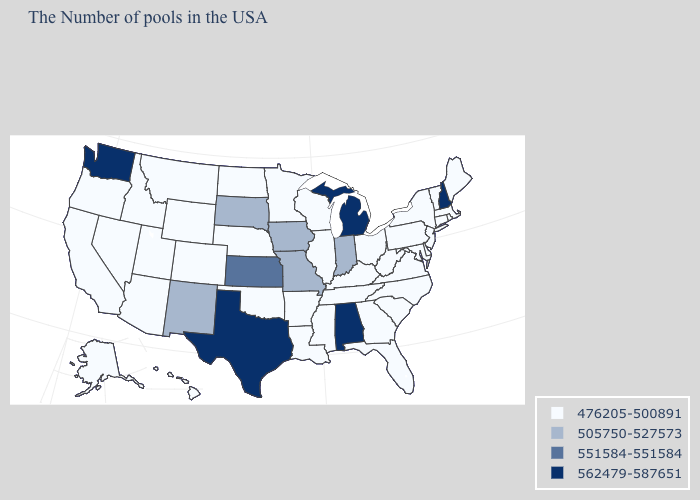Which states hav the highest value in the Northeast?
Concise answer only. New Hampshire. Name the states that have a value in the range 551584-551584?
Quick response, please. Kansas. Is the legend a continuous bar?
Be succinct. No. Does the map have missing data?
Quick response, please. No. Which states hav the highest value in the South?
Concise answer only. Alabama, Texas. Name the states that have a value in the range 476205-500891?
Be succinct. Maine, Massachusetts, Rhode Island, Vermont, Connecticut, New York, New Jersey, Delaware, Maryland, Pennsylvania, Virginia, North Carolina, South Carolina, West Virginia, Ohio, Florida, Georgia, Kentucky, Tennessee, Wisconsin, Illinois, Mississippi, Louisiana, Arkansas, Minnesota, Nebraska, Oklahoma, North Dakota, Wyoming, Colorado, Utah, Montana, Arizona, Idaho, Nevada, California, Oregon, Alaska, Hawaii. Among the states that border North Dakota , which have the highest value?
Write a very short answer. South Dakota. Among the states that border Michigan , which have the lowest value?
Be succinct. Ohio, Wisconsin. How many symbols are there in the legend?
Keep it brief. 4. What is the highest value in the South ?
Write a very short answer. 562479-587651. Does New Jersey have the same value as California?
Answer briefly. Yes. What is the value of Kentucky?
Concise answer only. 476205-500891. How many symbols are there in the legend?
Give a very brief answer. 4. What is the highest value in the USA?
Quick response, please. 562479-587651. 